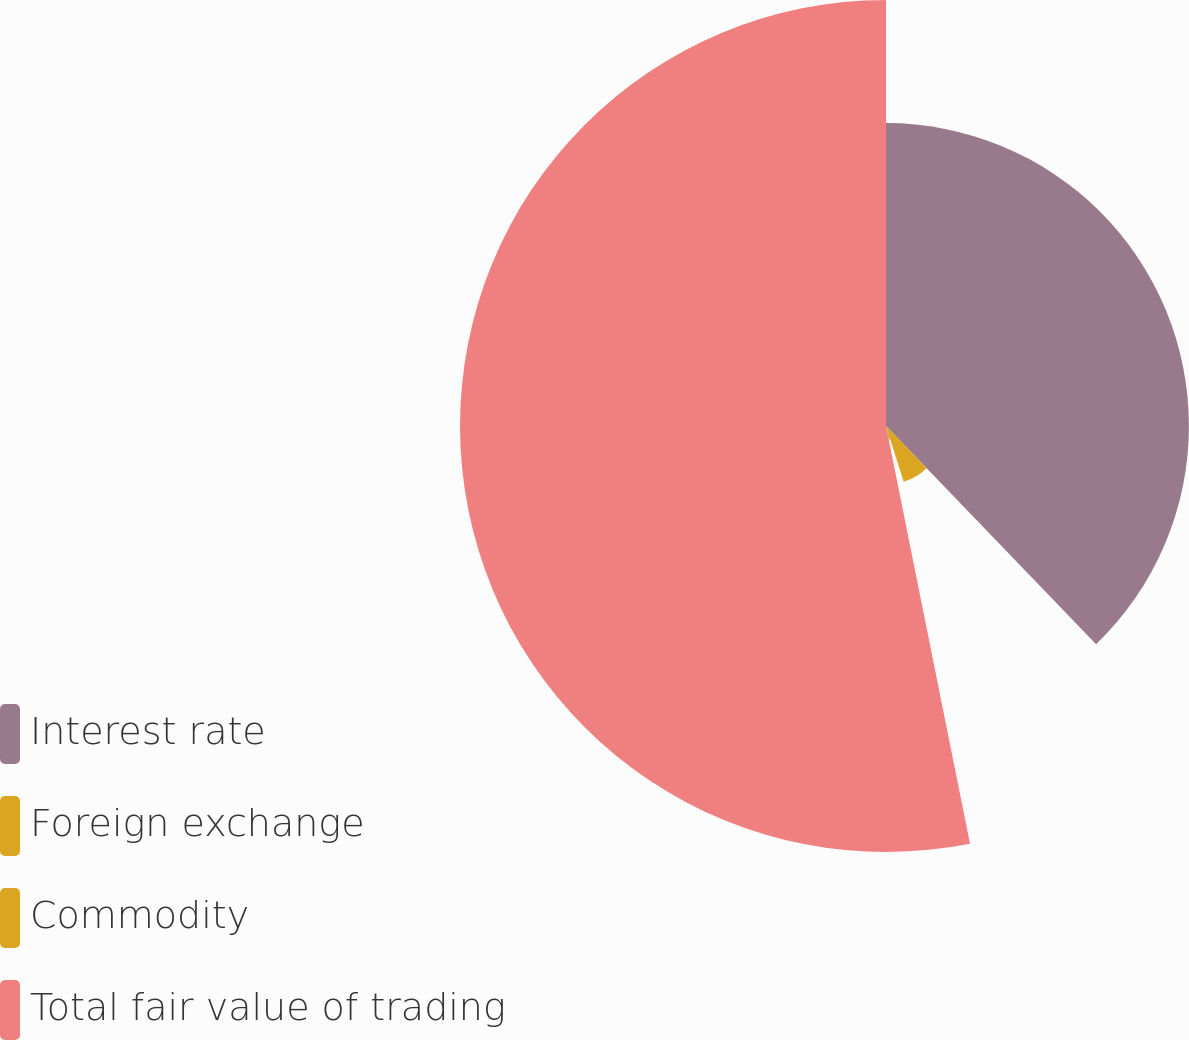<chart> <loc_0><loc_0><loc_500><loc_500><pie_chart><fcel>Interest rate<fcel>Foreign exchange<fcel>Commodity<fcel>Total fair value of trading<nl><fcel>37.8%<fcel>7.31%<fcel>1.73%<fcel>53.16%<nl></chart> 